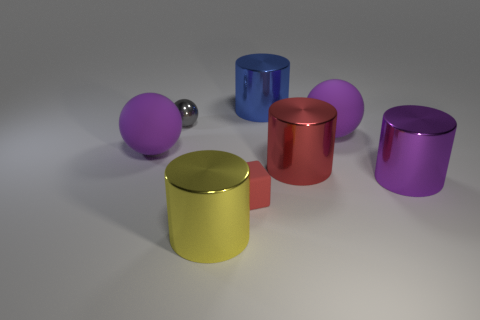Subtract all purple spheres. How many spheres are left? 1 Subtract all purple balls. How many balls are left? 1 Subtract all blocks. How many objects are left? 7 Subtract 2 balls. How many balls are left? 1 Subtract all purple cubes. Subtract all gray cylinders. How many cubes are left? 1 Subtract all cyan balls. How many blue cylinders are left? 1 Subtract all large purple shiny cylinders. Subtract all matte spheres. How many objects are left? 5 Add 4 yellow metal things. How many yellow metal things are left? 5 Add 1 yellow cylinders. How many yellow cylinders exist? 2 Add 2 red metal cylinders. How many objects exist? 10 